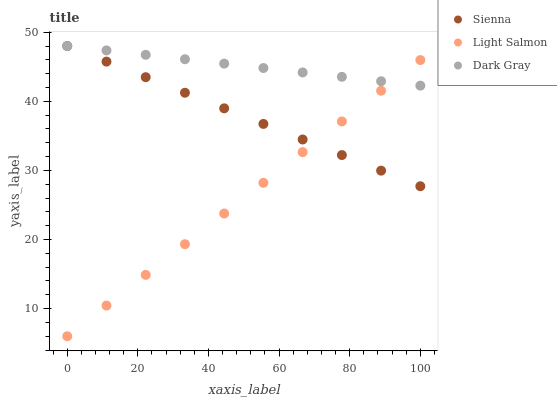Does Light Salmon have the minimum area under the curve?
Answer yes or no. Yes. Does Dark Gray have the maximum area under the curve?
Answer yes or no. Yes. Does Dark Gray have the minimum area under the curve?
Answer yes or no. No. Does Light Salmon have the maximum area under the curve?
Answer yes or no. No. Is Light Salmon the smoothest?
Answer yes or no. Yes. Is Dark Gray the roughest?
Answer yes or no. Yes. Is Dark Gray the smoothest?
Answer yes or no. No. Is Light Salmon the roughest?
Answer yes or no. No. Does Light Salmon have the lowest value?
Answer yes or no. Yes. Does Dark Gray have the lowest value?
Answer yes or no. No. Does Dark Gray have the highest value?
Answer yes or no. Yes. Does Light Salmon have the highest value?
Answer yes or no. No. Does Dark Gray intersect Light Salmon?
Answer yes or no. Yes. Is Dark Gray less than Light Salmon?
Answer yes or no. No. Is Dark Gray greater than Light Salmon?
Answer yes or no. No. 